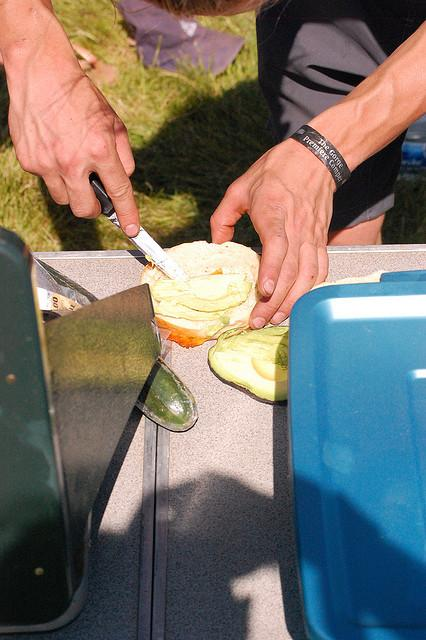At what type event is the man preparing food?

Choices:
A) fancy brunch
B) bris
C) picnic
D) baby shower picnic 